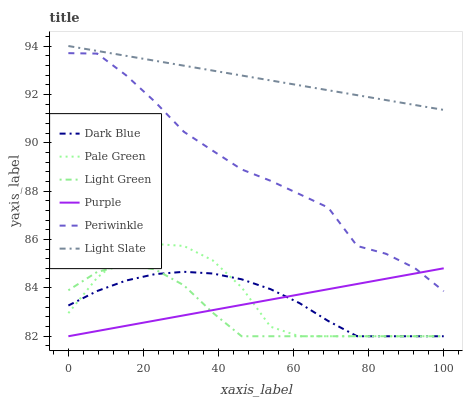Does Light Green have the minimum area under the curve?
Answer yes or no. Yes. Does Light Slate have the maximum area under the curve?
Answer yes or no. Yes. Does Dark Blue have the minimum area under the curve?
Answer yes or no. No. Does Dark Blue have the maximum area under the curve?
Answer yes or no. No. Is Purple the smoothest?
Answer yes or no. Yes. Is Periwinkle the roughest?
Answer yes or no. Yes. Is Light Slate the smoothest?
Answer yes or no. No. Is Light Slate the roughest?
Answer yes or no. No. Does Purple have the lowest value?
Answer yes or no. Yes. Does Light Slate have the lowest value?
Answer yes or no. No. Does Light Slate have the highest value?
Answer yes or no. Yes. Does Dark Blue have the highest value?
Answer yes or no. No. Is Periwinkle less than Light Slate?
Answer yes or no. Yes. Is Light Slate greater than Dark Blue?
Answer yes or no. Yes. Does Purple intersect Light Green?
Answer yes or no. Yes. Is Purple less than Light Green?
Answer yes or no. No. Is Purple greater than Light Green?
Answer yes or no. No. Does Periwinkle intersect Light Slate?
Answer yes or no. No. 